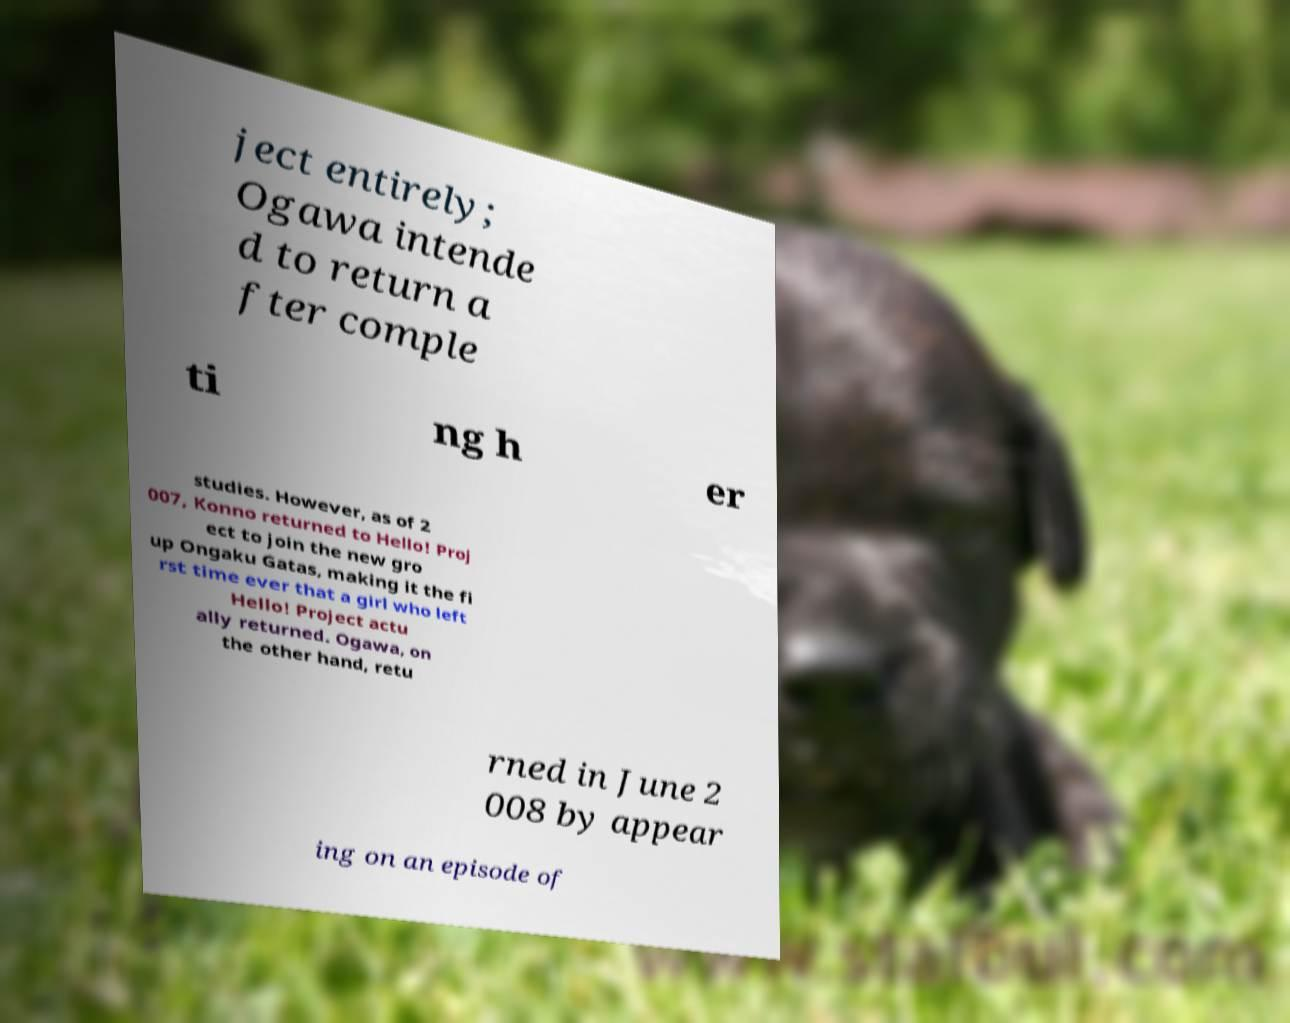Can you read and provide the text displayed in the image?This photo seems to have some interesting text. Can you extract and type it out for me? ject entirely; Ogawa intende d to return a fter comple ti ng h er studies. However, as of 2 007, Konno returned to Hello! Proj ect to join the new gro up Ongaku Gatas, making it the fi rst time ever that a girl who left Hello! Project actu ally returned. Ogawa, on the other hand, retu rned in June 2 008 by appear ing on an episode of 